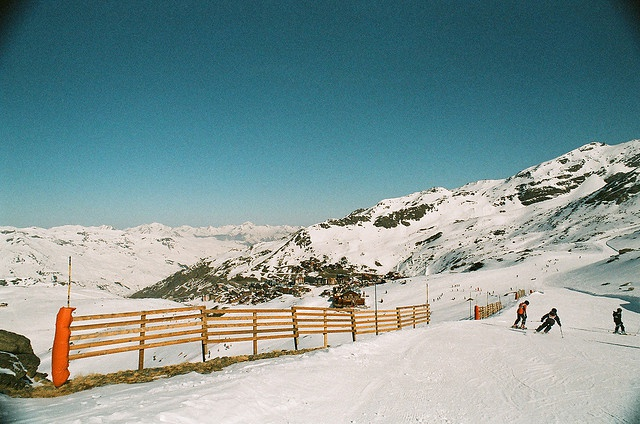Describe the objects in this image and their specific colors. I can see people in black, ivory, gray, and darkgray tones, people in black, maroon, and gray tones, people in black, gray, darkgray, and teal tones, skis in black, darkgray, gray, and lightgray tones, and skis in black, darkgray, lightgray, and gray tones in this image. 